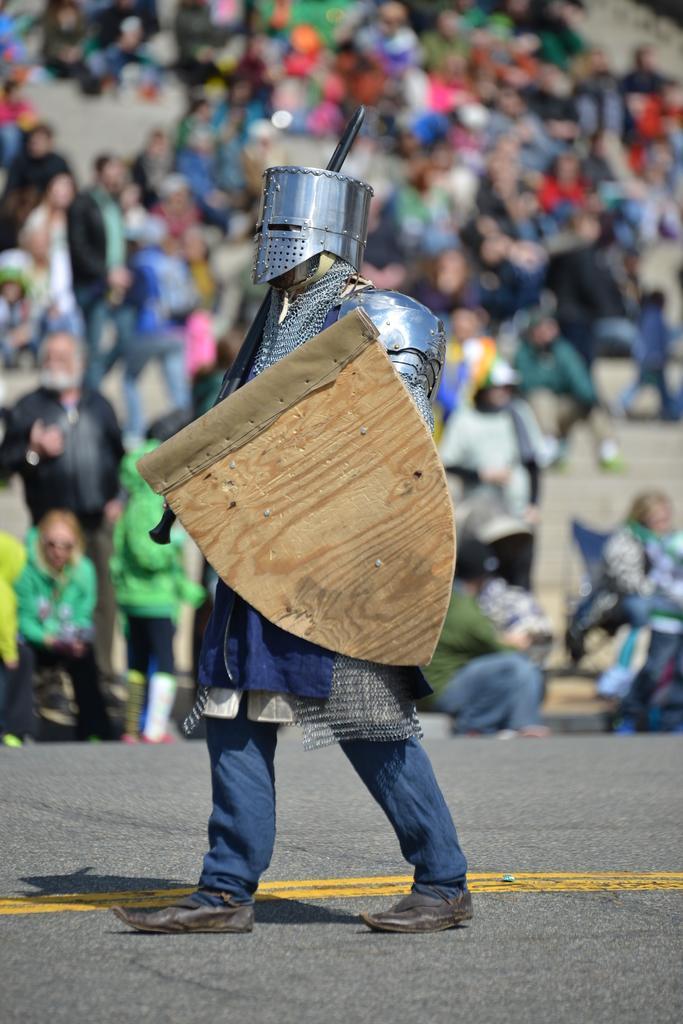Describe this image in one or two sentences. In this image we can see persons sitting and standing on the floor. In the foreground we can see wearing armors and holding a stick in his hands. 